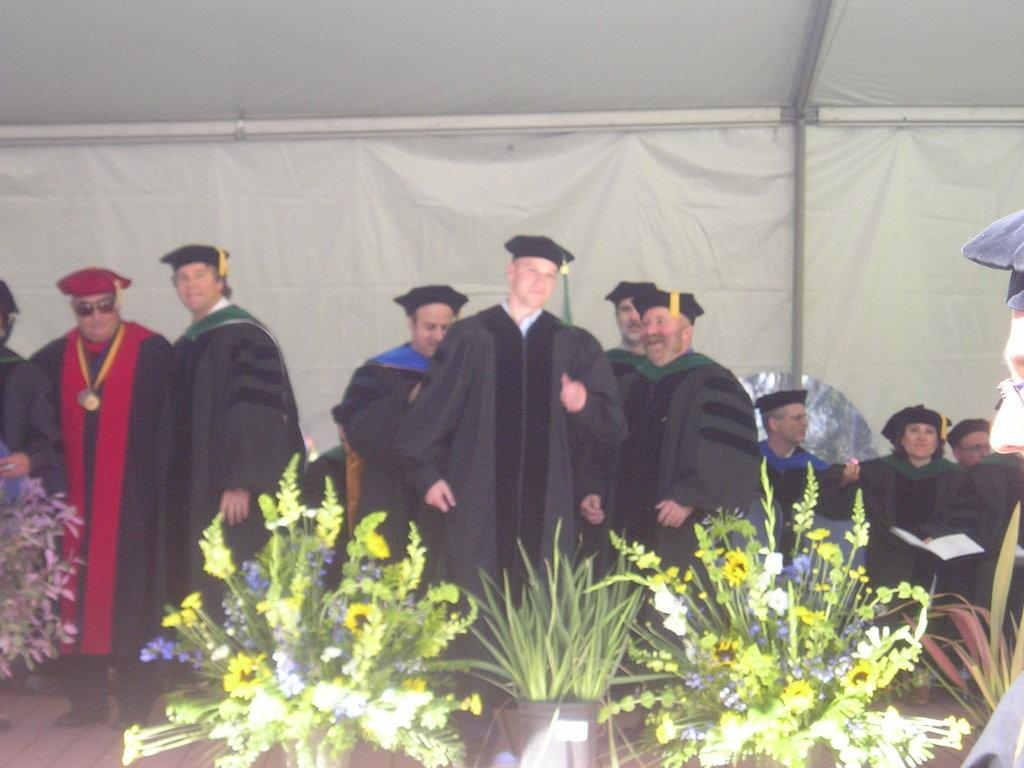What are the people in the image wearing? The people in the image are wearing academic dresses. What type of containers can be seen in the image? There are plant pots and flower pots in the image. What type of cherry is being used as a decoration in the image? There is no cherry present in the image. Can you describe the journey of the insect in the image? There is no insect present in the image, so it is not possible to describe its journey. 